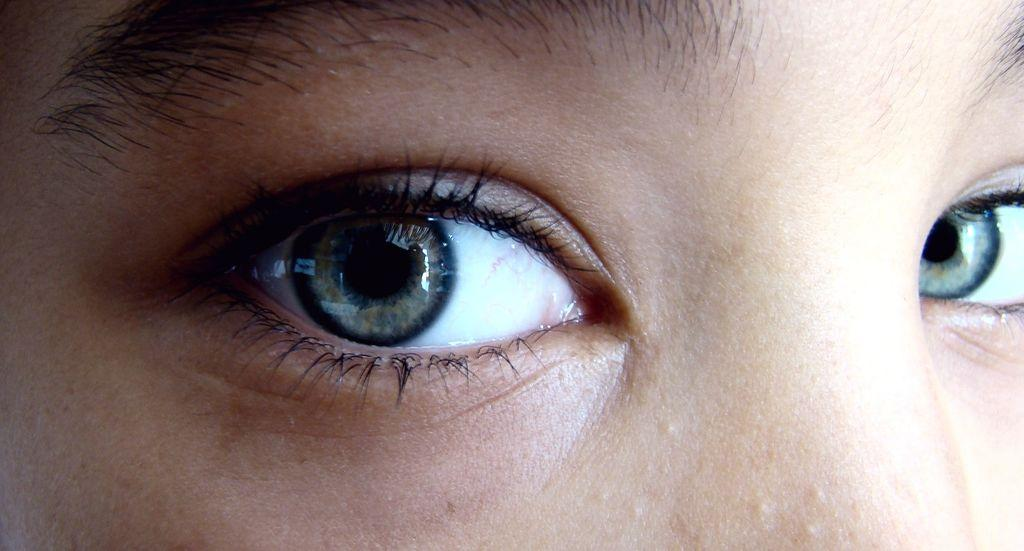What body parts are featured in the image? There are human eyes in the image. What additional features can be seen around the eyes? Eyelashes and eyebrows are visible in the image. What type of skin is visible in the image? Human skin is visible in the image. Can you tell me how many light bulbs are present in the image? There are no light bulbs present in the image; it features human eyes, eyelashes, eyebrows, and human skin. How does the person with the eyes in the image swim? There is no indication in the image that the person with the eyes is swimming or engaging in any water-based activity. 